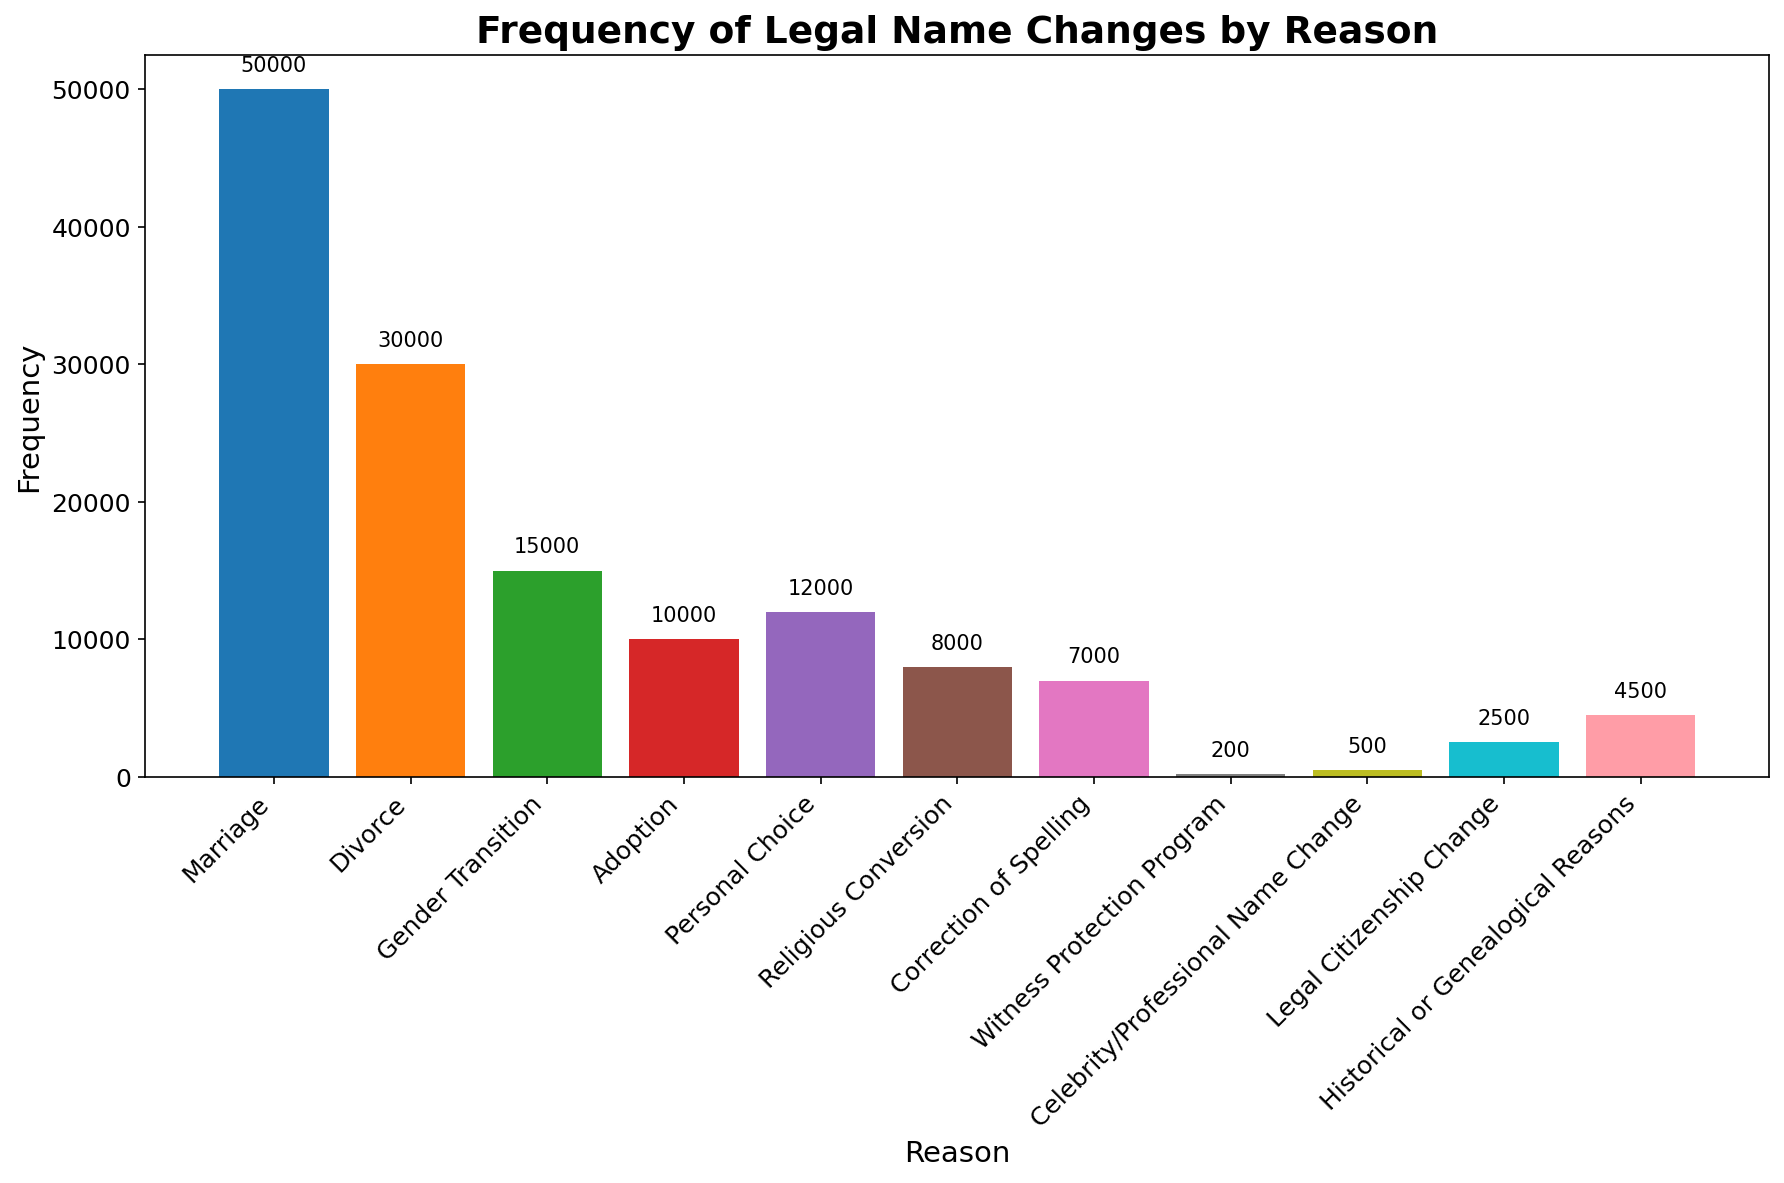What is the most common reason for legal name changes according to the figure? To find which reason has the highest frequency, we look for the tallest bar in the bar chart. The bar for "Marriage" is the tallest with a frequency of 50,000.
Answer: Marriage How many more legal name changes are due to Marriage than Adoption? The frequency for Marriage is 50,000 and for Adoption is 10,000. The difference is 50,000 - 10,000 = 40,000.
Answer: 40,000 Which category has the least frequency of legal name changes? The bar with the shortest height represents the least frequency, which is for "Witness Protection Program" with a frequency of 200.
Answer: Witness Protection Program Are legal name changes due to Gender Transition more or less frequent than due to Divorce? The frequency for Gender Transition is 15,000, and for Divorce, it is 30,000. Comparing the two, 15,000 is less than 30,000.
Answer: Less What is the total frequency of legal name changes for Marriage and Divorce combined? To find the combined frequency, we sum the frequencies of Marriage and Divorce: 50,000 + 30,000 = 80,000.
Answer: 80,000 Which reasons have more than 10,000 legal name changes? By examining the bars, we see that "Marriage," "Divorce," "Gender Transition," and "Personal Choice" each have frequencies higher than 10,000.
Answer: Marriage, Divorce, Gender Transition, Personal Choice What is the average frequency of legal name changes for Adoption, Religious Conversion, and Correction of Spelling? To find the average, sum the frequencies and divide by the number of categories: (10,000 + 8,000 + 7,000) / 3 = 25,000 / 3 ≈ 8,333.33.
Answer: 8,333.33 Which reason has a frequency closest to 5,000? By observing the bars, we see that "Historical or Genealogical Reasons" has a frequency of 4,500, which is closest to 5,000.
Answer: Historical or Genealogical Reasons Is the frequency of legal name changes due to Legal Citizenship Change greater than Religious Conversion? The frequency for Legal Citizenship Change is 2,500, and for Religious Conversion, it is 8,000. 2,500 is less than 8,000.
Answer: No How many total legal name changes are there for all reasons combined? Sum the frequency of all reasons: 50,000 + 30,000 + 15,000 + 10,000 + 12,000 + 8,000 + 7,000 + 200 + 500 + 2,500 + 4,500 = 139,700.
Answer: 139,700 